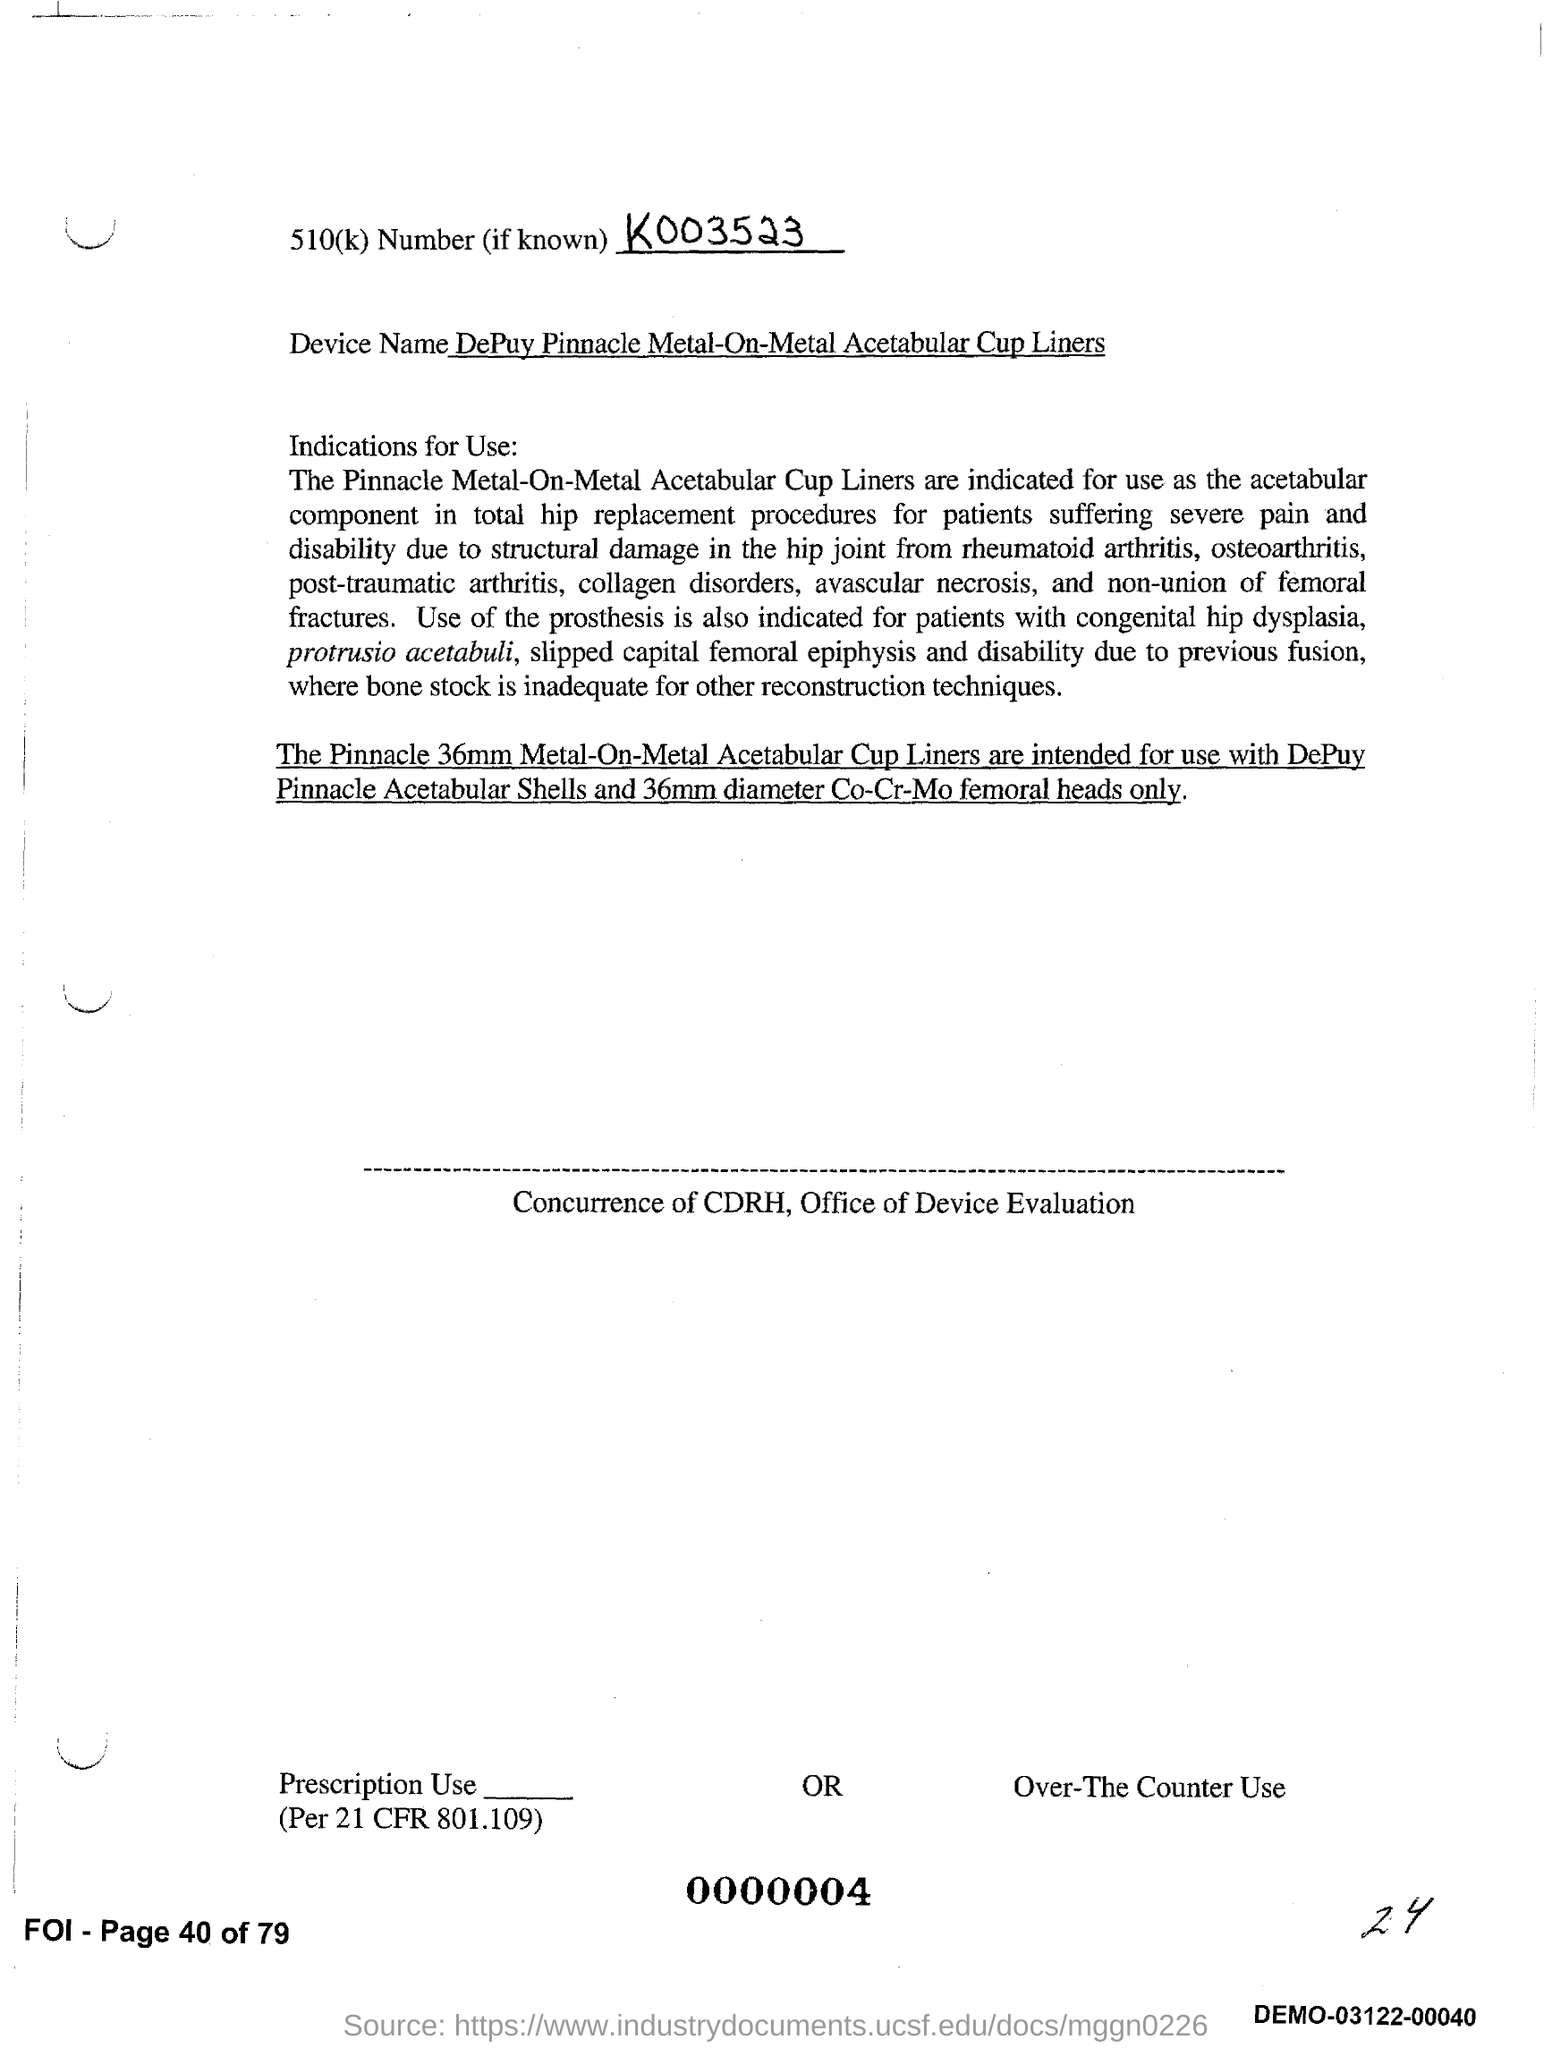What is the 510(k) Number?
Provide a succinct answer. K003523. What is the device name?
Your answer should be compact. DePuy Pinnacle Metal-On-Metal Acetabular Cup Liners. 